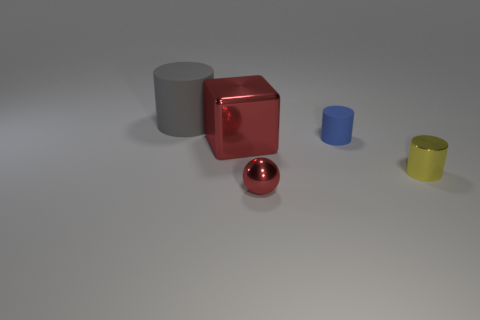How would you describe the composition and balance of the image? The composition has an asymmetrical balance with objects of varying sizes and colors spaced out across the space. The larger gray cylinder anchors the composition on the left, balanced by the array of smaller objects that lead the eye across the image to the right. Does the positioning of the objects suggest any particular perspective or focal point? Yes, the larger red cube in the middle serves as a focal point due to its central position, vivid color, and reflecting surface. The arrangement of the objects in decreasing size order from left to right also creates a perspective that leads the viewer's gaze toward the red cube. 